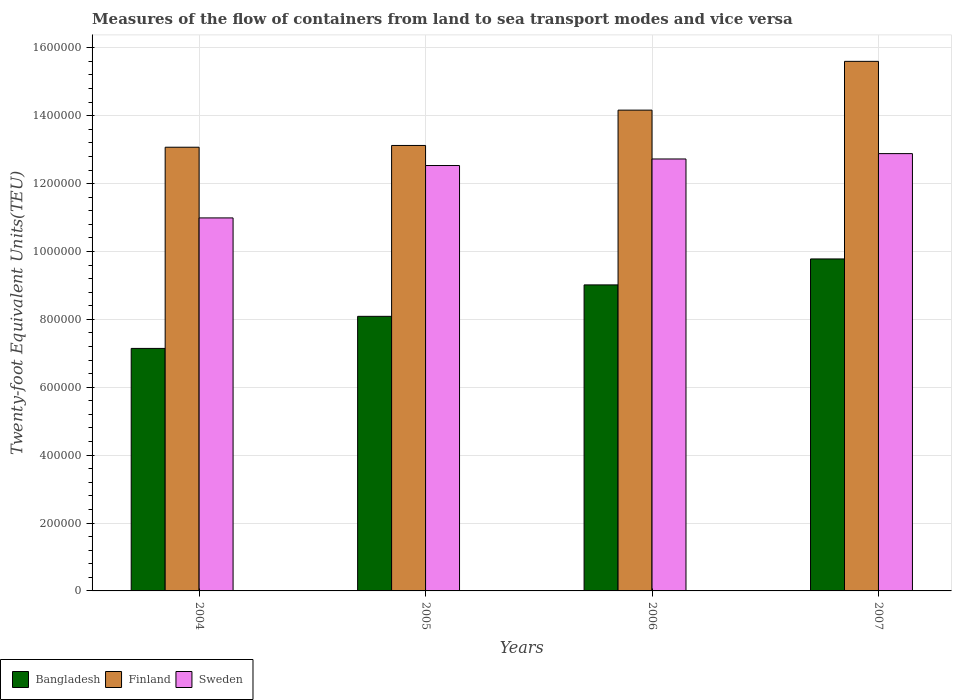How many bars are there on the 4th tick from the right?
Provide a short and direct response. 3. In how many cases, is the number of bars for a given year not equal to the number of legend labels?
Your response must be concise. 0. What is the container port traffic in Sweden in 2005?
Give a very brief answer. 1.25e+06. Across all years, what is the maximum container port traffic in Finland?
Provide a short and direct response. 1.56e+06. Across all years, what is the minimum container port traffic in Sweden?
Offer a very short reply. 1.10e+06. In which year was the container port traffic in Bangladesh maximum?
Your answer should be very brief. 2007. In which year was the container port traffic in Bangladesh minimum?
Provide a short and direct response. 2004. What is the total container port traffic in Finland in the graph?
Ensure brevity in your answer.  5.60e+06. What is the difference between the container port traffic in Sweden in 2005 and that in 2007?
Ensure brevity in your answer.  -3.51e+04. What is the difference between the container port traffic in Sweden in 2007 and the container port traffic in Bangladesh in 2005?
Keep it short and to the point. 4.79e+05. What is the average container port traffic in Finland per year?
Your answer should be very brief. 1.40e+06. In the year 2004, what is the difference between the container port traffic in Sweden and container port traffic in Finland?
Offer a very short reply. -2.08e+05. What is the ratio of the container port traffic in Finland in 2006 to that in 2007?
Make the answer very short. 0.91. Is the container port traffic in Finland in 2005 less than that in 2006?
Your answer should be compact. Yes. Is the difference between the container port traffic in Sweden in 2004 and 2005 greater than the difference between the container port traffic in Finland in 2004 and 2005?
Your response must be concise. No. What is the difference between the highest and the second highest container port traffic in Bangladesh?
Offer a very short reply. 7.65e+04. What is the difference between the highest and the lowest container port traffic in Sweden?
Give a very brief answer. 1.89e+05. In how many years, is the container port traffic in Bangladesh greater than the average container port traffic in Bangladesh taken over all years?
Keep it short and to the point. 2. What does the 3rd bar from the left in 2004 represents?
Ensure brevity in your answer.  Sweden. Is it the case that in every year, the sum of the container port traffic in Bangladesh and container port traffic in Finland is greater than the container port traffic in Sweden?
Offer a terse response. Yes. Are all the bars in the graph horizontal?
Provide a short and direct response. No. What is the difference between two consecutive major ticks on the Y-axis?
Make the answer very short. 2.00e+05. Are the values on the major ticks of Y-axis written in scientific E-notation?
Your answer should be compact. No. Does the graph contain grids?
Keep it short and to the point. Yes. Where does the legend appear in the graph?
Give a very brief answer. Bottom left. How many legend labels are there?
Keep it short and to the point. 3. How are the legend labels stacked?
Give a very brief answer. Horizontal. What is the title of the graph?
Ensure brevity in your answer.  Measures of the flow of containers from land to sea transport modes and vice versa. Does "West Bank and Gaza" appear as one of the legend labels in the graph?
Offer a very short reply. No. What is the label or title of the Y-axis?
Ensure brevity in your answer.  Twenty-foot Equivalent Units(TEU). What is the Twenty-foot Equivalent Units(TEU) in Bangladesh in 2004?
Your answer should be very brief. 7.14e+05. What is the Twenty-foot Equivalent Units(TEU) of Finland in 2004?
Your answer should be very brief. 1.31e+06. What is the Twenty-foot Equivalent Units(TEU) in Sweden in 2004?
Provide a short and direct response. 1.10e+06. What is the Twenty-foot Equivalent Units(TEU) of Bangladesh in 2005?
Give a very brief answer. 8.09e+05. What is the Twenty-foot Equivalent Units(TEU) in Finland in 2005?
Offer a very short reply. 1.31e+06. What is the Twenty-foot Equivalent Units(TEU) in Sweden in 2005?
Keep it short and to the point. 1.25e+06. What is the Twenty-foot Equivalent Units(TEU) of Bangladesh in 2006?
Offer a terse response. 9.02e+05. What is the Twenty-foot Equivalent Units(TEU) of Finland in 2006?
Make the answer very short. 1.42e+06. What is the Twenty-foot Equivalent Units(TEU) of Sweden in 2006?
Make the answer very short. 1.27e+06. What is the Twenty-foot Equivalent Units(TEU) of Bangladesh in 2007?
Your answer should be very brief. 9.78e+05. What is the Twenty-foot Equivalent Units(TEU) in Finland in 2007?
Keep it short and to the point. 1.56e+06. What is the Twenty-foot Equivalent Units(TEU) in Sweden in 2007?
Offer a very short reply. 1.29e+06. Across all years, what is the maximum Twenty-foot Equivalent Units(TEU) in Bangladesh?
Provide a short and direct response. 9.78e+05. Across all years, what is the maximum Twenty-foot Equivalent Units(TEU) of Finland?
Your answer should be very brief. 1.56e+06. Across all years, what is the maximum Twenty-foot Equivalent Units(TEU) in Sweden?
Keep it short and to the point. 1.29e+06. Across all years, what is the minimum Twenty-foot Equivalent Units(TEU) in Bangladesh?
Your response must be concise. 7.14e+05. Across all years, what is the minimum Twenty-foot Equivalent Units(TEU) of Finland?
Keep it short and to the point. 1.31e+06. Across all years, what is the minimum Twenty-foot Equivalent Units(TEU) in Sweden?
Give a very brief answer. 1.10e+06. What is the total Twenty-foot Equivalent Units(TEU) of Bangladesh in the graph?
Offer a very short reply. 3.40e+06. What is the total Twenty-foot Equivalent Units(TEU) in Finland in the graph?
Offer a very short reply. 5.60e+06. What is the total Twenty-foot Equivalent Units(TEU) of Sweden in the graph?
Your response must be concise. 4.91e+06. What is the difference between the Twenty-foot Equivalent Units(TEU) in Bangladesh in 2004 and that in 2005?
Make the answer very short. -9.45e+04. What is the difference between the Twenty-foot Equivalent Units(TEU) of Finland in 2004 and that in 2005?
Keep it short and to the point. -5213. What is the difference between the Twenty-foot Equivalent Units(TEU) of Sweden in 2004 and that in 2005?
Your response must be concise. -1.54e+05. What is the difference between the Twenty-foot Equivalent Units(TEU) of Bangladesh in 2004 and that in 2006?
Your answer should be compact. -1.87e+05. What is the difference between the Twenty-foot Equivalent Units(TEU) in Finland in 2004 and that in 2006?
Make the answer very short. -1.09e+05. What is the difference between the Twenty-foot Equivalent Units(TEU) of Sweden in 2004 and that in 2006?
Offer a very short reply. -1.74e+05. What is the difference between the Twenty-foot Equivalent Units(TEU) in Bangladesh in 2004 and that in 2007?
Keep it short and to the point. -2.64e+05. What is the difference between the Twenty-foot Equivalent Units(TEU) in Finland in 2004 and that in 2007?
Your response must be concise. -2.53e+05. What is the difference between the Twenty-foot Equivalent Units(TEU) of Sweden in 2004 and that in 2007?
Give a very brief answer. -1.89e+05. What is the difference between the Twenty-foot Equivalent Units(TEU) of Bangladesh in 2005 and that in 2006?
Give a very brief answer. -9.26e+04. What is the difference between the Twenty-foot Equivalent Units(TEU) of Finland in 2005 and that in 2006?
Your response must be concise. -1.04e+05. What is the difference between the Twenty-foot Equivalent Units(TEU) of Sweden in 2005 and that in 2006?
Provide a short and direct response. -1.93e+04. What is the difference between the Twenty-foot Equivalent Units(TEU) in Bangladesh in 2005 and that in 2007?
Provide a short and direct response. -1.69e+05. What is the difference between the Twenty-foot Equivalent Units(TEU) in Finland in 2005 and that in 2007?
Keep it short and to the point. -2.48e+05. What is the difference between the Twenty-foot Equivalent Units(TEU) in Sweden in 2005 and that in 2007?
Offer a very short reply. -3.51e+04. What is the difference between the Twenty-foot Equivalent Units(TEU) of Bangladesh in 2006 and that in 2007?
Ensure brevity in your answer.  -7.65e+04. What is the difference between the Twenty-foot Equivalent Units(TEU) in Finland in 2006 and that in 2007?
Provide a short and direct response. -1.44e+05. What is the difference between the Twenty-foot Equivalent Units(TEU) of Sweden in 2006 and that in 2007?
Your answer should be very brief. -1.58e+04. What is the difference between the Twenty-foot Equivalent Units(TEU) in Bangladesh in 2004 and the Twenty-foot Equivalent Units(TEU) in Finland in 2005?
Give a very brief answer. -5.98e+05. What is the difference between the Twenty-foot Equivalent Units(TEU) of Bangladesh in 2004 and the Twenty-foot Equivalent Units(TEU) of Sweden in 2005?
Your answer should be very brief. -5.39e+05. What is the difference between the Twenty-foot Equivalent Units(TEU) of Finland in 2004 and the Twenty-foot Equivalent Units(TEU) of Sweden in 2005?
Offer a terse response. 5.39e+04. What is the difference between the Twenty-foot Equivalent Units(TEU) in Bangladesh in 2004 and the Twenty-foot Equivalent Units(TEU) in Finland in 2006?
Provide a succinct answer. -7.02e+05. What is the difference between the Twenty-foot Equivalent Units(TEU) in Bangladesh in 2004 and the Twenty-foot Equivalent Units(TEU) in Sweden in 2006?
Provide a short and direct response. -5.58e+05. What is the difference between the Twenty-foot Equivalent Units(TEU) in Finland in 2004 and the Twenty-foot Equivalent Units(TEU) in Sweden in 2006?
Give a very brief answer. 3.46e+04. What is the difference between the Twenty-foot Equivalent Units(TEU) of Bangladesh in 2004 and the Twenty-foot Equivalent Units(TEU) of Finland in 2007?
Provide a short and direct response. -8.46e+05. What is the difference between the Twenty-foot Equivalent Units(TEU) of Bangladesh in 2004 and the Twenty-foot Equivalent Units(TEU) of Sweden in 2007?
Your response must be concise. -5.74e+05. What is the difference between the Twenty-foot Equivalent Units(TEU) of Finland in 2004 and the Twenty-foot Equivalent Units(TEU) of Sweden in 2007?
Offer a terse response. 1.88e+04. What is the difference between the Twenty-foot Equivalent Units(TEU) of Bangladesh in 2005 and the Twenty-foot Equivalent Units(TEU) of Finland in 2006?
Ensure brevity in your answer.  -6.07e+05. What is the difference between the Twenty-foot Equivalent Units(TEU) in Bangladesh in 2005 and the Twenty-foot Equivalent Units(TEU) in Sweden in 2006?
Provide a short and direct response. -4.64e+05. What is the difference between the Twenty-foot Equivalent Units(TEU) of Finland in 2005 and the Twenty-foot Equivalent Units(TEU) of Sweden in 2006?
Provide a succinct answer. 3.98e+04. What is the difference between the Twenty-foot Equivalent Units(TEU) in Bangladesh in 2005 and the Twenty-foot Equivalent Units(TEU) in Finland in 2007?
Your response must be concise. -7.51e+05. What is the difference between the Twenty-foot Equivalent Units(TEU) of Bangladesh in 2005 and the Twenty-foot Equivalent Units(TEU) of Sweden in 2007?
Ensure brevity in your answer.  -4.79e+05. What is the difference between the Twenty-foot Equivalent Units(TEU) of Finland in 2005 and the Twenty-foot Equivalent Units(TEU) of Sweden in 2007?
Your answer should be very brief. 2.40e+04. What is the difference between the Twenty-foot Equivalent Units(TEU) in Bangladesh in 2006 and the Twenty-foot Equivalent Units(TEU) in Finland in 2007?
Give a very brief answer. -6.59e+05. What is the difference between the Twenty-foot Equivalent Units(TEU) of Bangladesh in 2006 and the Twenty-foot Equivalent Units(TEU) of Sweden in 2007?
Your answer should be very brief. -3.87e+05. What is the difference between the Twenty-foot Equivalent Units(TEU) in Finland in 2006 and the Twenty-foot Equivalent Units(TEU) in Sweden in 2007?
Offer a terse response. 1.28e+05. What is the average Twenty-foot Equivalent Units(TEU) in Bangladesh per year?
Your answer should be very brief. 8.51e+05. What is the average Twenty-foot Equivalent Units(TEU) of Finland per year?
Your answer should be very brief. 1.40e+06. What is the average Twenty-foot Equivalent Units(TEU) of Sweden per year?
Your answer should be very brief. 1.23e+06. In the year 2004, what is the difference between the Twenty-foot Equivalent Units(TEU) in Bangladesh and Twenty-foot Equivalent Units(TEU) in Finland?
Your response must be concise. -5.93e+05. In the year 2004, what is the difference between the Twenty-foot Equivalent Units(TEU) in Bangladesh and Twenty-foot Equivalent Units(TEU) in Sweden?
Give a very brief answer. -3.84e+05. In the year 2004, what is the difference between the Twenty-foot Equivalent Units(TEU) in Finland and Twenty-foot Equivalent Units(TEU) in Sweden?
Your answer should be very brief. 2.08e+05. In the year 2005, what is the difference between the Twenty-foot Equivalent Units(TEU) in Bangladesh and Twenty-foot Equivalent Units(TEU) in Finland?
Offer a very short reply. -5.03e+05. In the year 2005, what is the difference between the Twenty-foot Equivalent Units(TEU) in Bangladesh and Twenty-foot Equivalent Units(TEU) in Sweden?
Provide a succinct answer. -4.44e+05. In the year 2005, what is the difference between the Twenty-foot Equivalent Units(TEU) of Finland and Twenty-foot Equivalent Units(TEU) of Sweden?
Make the answer very short. 5.91e+04. In the year 2006, what is the difference between the Twenty-foot Equivalent Units(TEU) in Bangladesh and Twenty-foot Equivalent Units(TEU) in Finland?
Provide a short and direct response. -5.15e+05. In the year 2006, what is the difference between the Twenty-foot Equivalent Units(TEU) of Bangladesh and Twenty-foot Equivalent Units(TEU) of Sweden?
Your answer should be compact. -3.71e+05. In the year 2006, what is the difference between the Twenty-foot Equivalent Units(TEU) in Finland and Twenty-foot Equivalent Units(TEU) in Sweden?
Your response must be concise. 1.44e+05. In the year 2007, what is the difference between the Twenty-foot Equivalent Units(TEU) of Bangladesh and Twenty-foot Equivalent Units(TEU) of Finland?
Ensure brevity in your answer.  -5.82e+05. In the year 2007, what is the difference between the Twenty-foot Equivalent Units(TEU) in Bangladesh and Twenty-foot Equivalent Units(TEU) in Sweden?
Give a very brief answer. -3.10e+05. In the year 2007, what is the difference between the Twenty-foot Equivalent Units(TEU) of Finland and Twenty-foot Equivalent Units(TEU) of Sweden?
Give a very brief answer. 2.72e+05. What is the ratio of the Twenty-foot Equivalent Units(TEU) of Bangladesh in 2004 to that in 2005?
Ensure brevity in your answer.  0.88. What is the ratio of the Twenty-foot Equivalent Units(TEU) in Finland in 2004 to that in 2005?
Ensure brevity in your answer.  1. What is the ratio of the Twenty-foot Equivalent Units(TEU) in Sweden in 2004 to that in 2005?
Provide a short and direct response. 0.88. What is the ratio of the Twenty-foot Equivalent Units(TEU) in Bangladesh in 2004 to that in 2006?
Provide a succinct answer. 0.79. What is the ratio of the Twenty-foot Equivalent Units(TEU) of Finland in 2004 to that in 2006?
Provide a succinct answer. 0.92. What is the ratio of the Twenty-foot Equivalent Units(TEU) in Sweden in 2004 to that in 2006?
Make the answer very short. 0.86. What is the ratio of the Twenty-foot Equivalent Units(TEU) of Bangladesh in 2004 to that in 2007?
Keep it short and to the point. 0.73. What is the ratio of the Twenty-foot Equivalent Units(TEU) in Finland in 2004 to that in 2007?
Provide a short and direct response. 0.84. What is the ratio of the Twenty-foot Equivalent Units(TEU) of Sweden in 2004 to that in 2007?
Offer a very short reply. 0.85. What is the ratio of the Twenty-foot Equivalent Units(TEU) in Bangladesh in 2005 to that in 2006?
Your response must be concise. 0.9. What is the ratio of the Twenty-foot Equivalent Units(TEU) in Finland in 2005 to that in 2006?
Your response must be concise. 0.93. What is the ratio of the Twenty-foot Equivalent Units(TEU) of Sweden in 2005 to that in 2006?
Ensure brevity in your answer.  0.98. What is the ratio of the Twenty-foot Equivalent Units(TEU) of Bangladesh in 2005 to that in 2007?
Your answer should be very brief. 0.83. What is the ratio of the Twenty-foot Equivalent Units(TEU) in Finland in 2005 to that in 2007?
Ensure brevity in your answer.  0.84. What is the ratio of the Twenty-foot Equivalent Units(TEU) in Sweden in 2005 to that in 2007?
Make the answer very short. 0.97. What is the ratio of the Twenty-foot Equivalent Units(TEU) in Bangladesh in 2006 to that in 2007?
Give a very brief answer. 0.92. What is the ratio of the Twenty-foot Equivalent Units(TEU) of Finland in 2006 to that in 2007?
Offer a terse response. 0.91. What is the ratio of the Twenty-foot Equivalent Units(TEU) in Sweden in 2006 to that in 2007?
Provide a succinct answer. 0.99. What is the difference between the highest and the second highest Twenty-foot Equivalent Units(TEU) in Bangladesh?
Keep it short and to the point. 7.65e+04. What is the difference between the highest and the second highest Twenty-foot Equivalent Units(TEU) in Finland?
Your response must be concise. 1.44e+05. What is the difference between the highest and the second highest Twenty-foot Equivalent Units(TEU) of Sweden?
Provide a short and direct response. 1.58e+04. What is the difference between the highest and the lowest Twenty-foot Equivalent Units(TEU) in Bangladesh?
Keep it short and to the point. 2.64e+05. What is the difference between the highest and the lowest Twenty-foot Equivalent Units(TEU) in Finland?
Your answer should be very brief. 2.53e+05. What is the difference between the highest and the lowest Twenty-foot Equivalent Units(TEU) in Sweden?
Ensure brevity in your answer.  1.89e+05. 